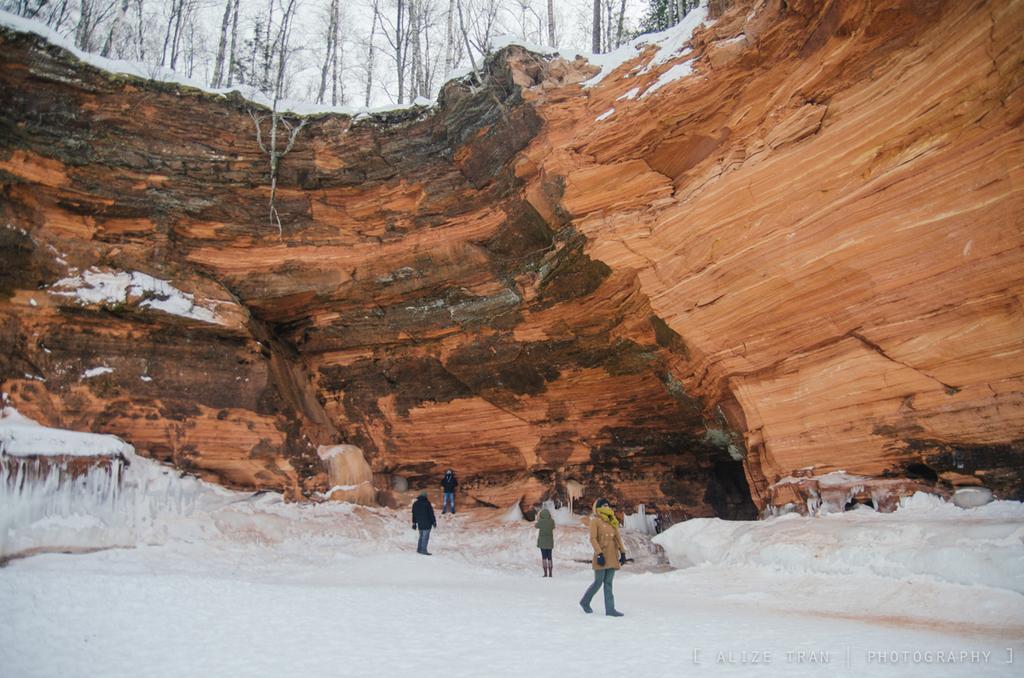Please provide a concise description of this image. In this image we can see a few people standing and walking on the surface of the snow behind them there is a big rock on top of the rock they are trees. 